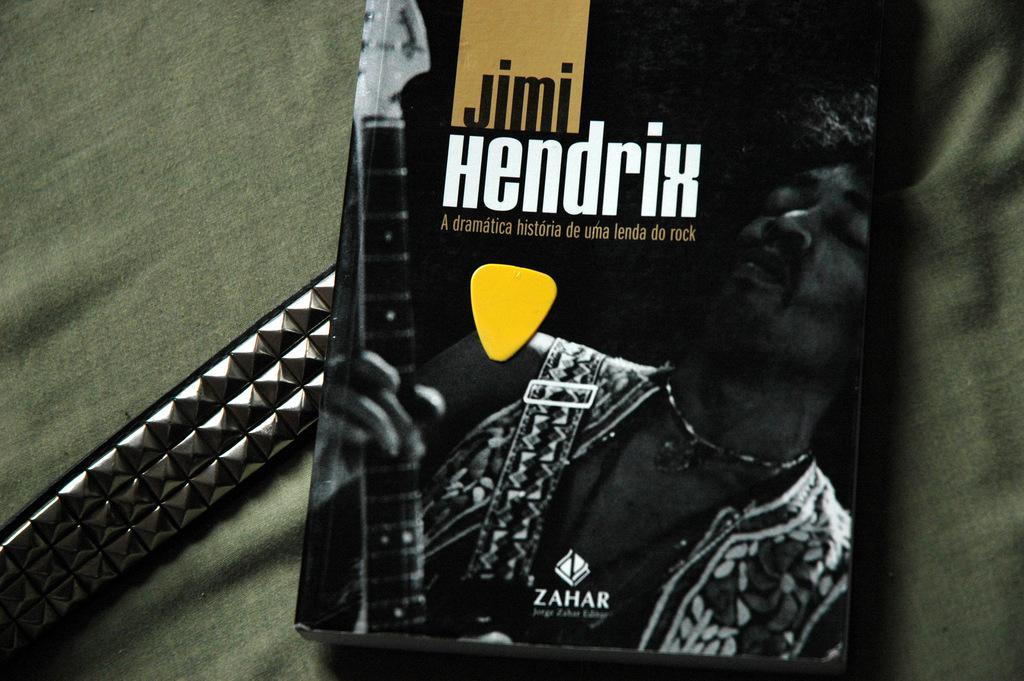<image>
Create a compact narrative representing the image presented. a book with Jimi Hendrix on the cover including his picture too. 